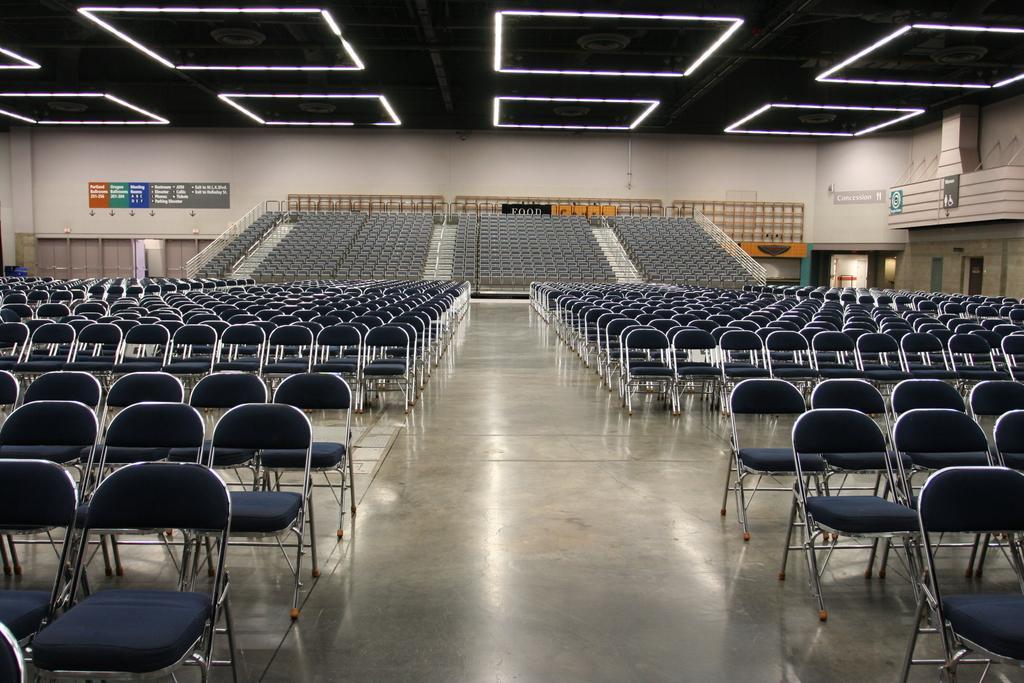In one or two sentences, can you explain what this image depicts? In this picture there are empty chairs. In the background there are boards with some text written on it and there is wall. 